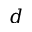Convert formula to latex. <formula><loc_0><loc_0><loc_500><loc_500>d</formula> 